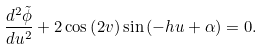Convert formula to latex. <formula><loc_0><loc_0><loc_500><loc_500>\frac { d ^ { 2 } \tilde { \phi } } { d u ^ { 2 } } + 2 \cos \left ( 2 v \right ) \sin \left ( - h u + \alpha \right ) = 0 .</formula> 